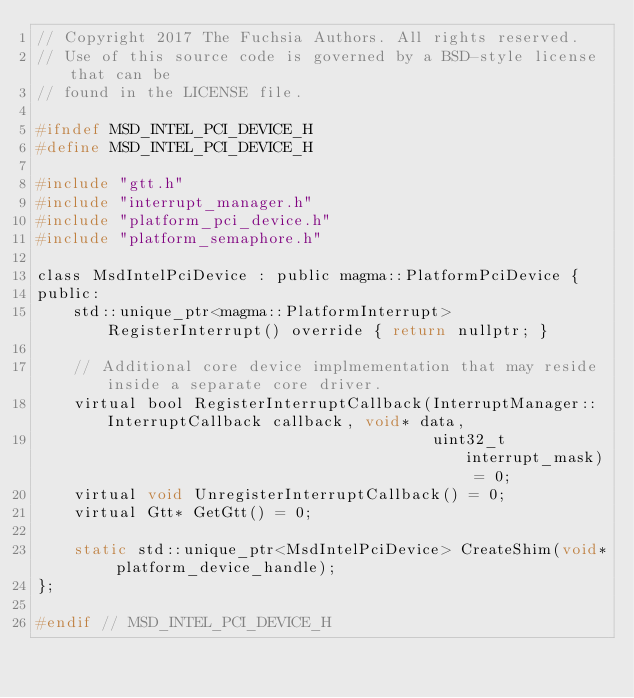Convert code to text. <code><loc_0><loc_0><loc_500><loc_500><_C_>// Copyright 2017 The Fuchsia Authors. All rights reserved.
// Use of this source code is governed by a BSD-style license that can be
// found in the LICENSE file.

#ifndef MSD_INTEL_PCI_DEVICE_H
#define MSD_INTEL_PCI_DEVICE_H

#include "gtt.h"
#include "interrupt_manager.h"
#include "platform_pci_device.h"
#include "platform_semaphore.h"

class MsdIntelPciDevice : public magma::PlatformPciDevice {
public:
    std::unique_ptr<magma::PlatformInterrupt> RegisterInterrupt() override { return nullptr; }

    // Additional core device implmementation that may reside inside a separate core driver.
    virtual bool RegisterInterruptCallback(InterruptManager::InterruptCallback callback, void* data,
                                           uint32_t interrupt_mask) = 0;
    virtual void UnregisterInterruptCallback() = 0;
    virtual Gtt* GetGtt() = 0;

    static std::unique_ptr<MsdIntelPciDevice> CreateShim(void* platform_device_handle);
};

#endif // MSD_INTEL_PCI_DEVICE_H
</code> 